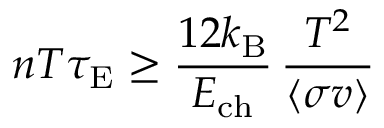<formula> <loc_0><loc_0><loc_500><loc_500>n T \tau _ { E } \geq { \frac { 1 2 k _ { B } } { E _ { c h } } } \, { \frac { T ^ { 2 } } { \langle \sigma v \rangle } }</formula> 